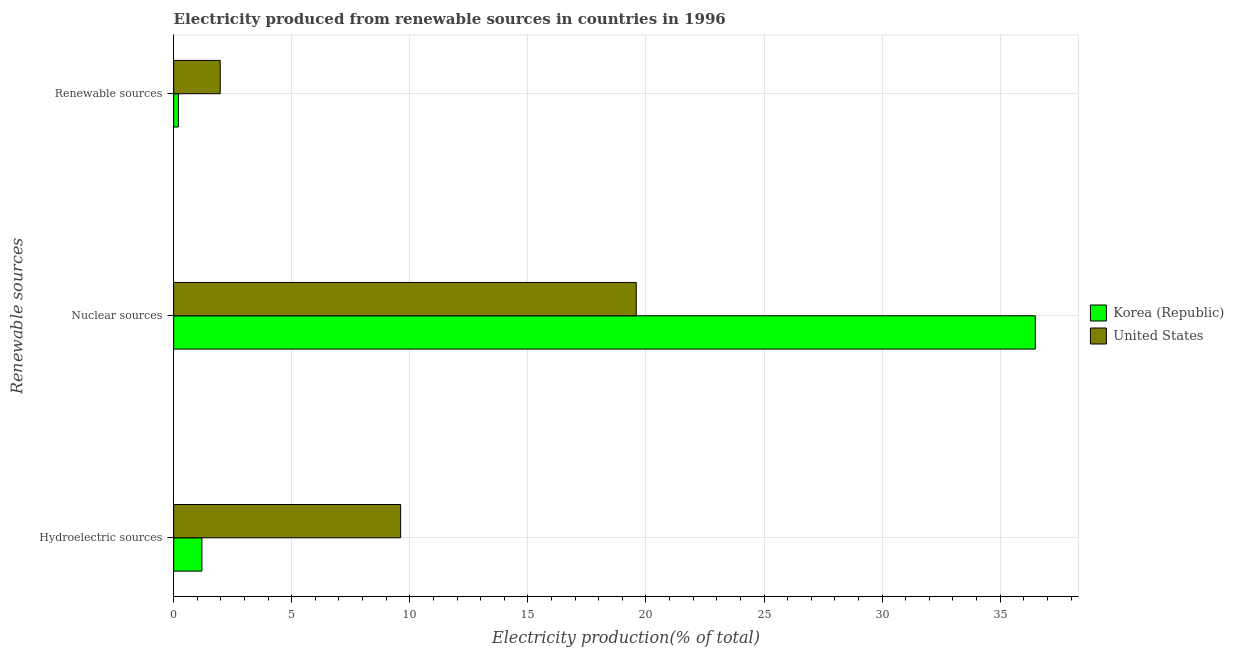How many different coloured bars are there?
Provide a succinct answer. 2. How many groups of bars are there?
Provide a short and direct response. 3. Are the number of bars per tick equal to the number of legend labels?
Offer a very short reply. Yes. Are the number of bars on each tick of the Y-axis equal?
Your response must be concise. Yes. How many bars are there on the 1st tick from the bottom?
Your answer should be very brief. 2. What is the label of the 2nd group of bars from the top?
Ensure brevity in your answer.  Nuclear sources. What is the percentage of electricity produced by hydroelectric sources in United States?
Keep it short and to the point. 9.61. Across all countries, what is the maximum percentage of electricity produced by hydroelectric sources?
Offer a terse response. 9.61. Across all countries, what is the minimum percentage of electricity produced by renewable sources?
Provide a short and direct response. 0.2. In which country was the percentage of electricity produced by hydroelectric sources maximum?
Offer a terse response. United States. What is the total percentage of electricity produced by renewable sources in the graph?
Give a very brief answer. 2.17. What is the difference between the percentage of electricity produced by nuclear sources in United States and that in Korea (Republic)?
Offer a terse response. -16.9. What is the difference between the percentage of electricity produced by nuclear sources in Korea (Republic) and the percentage of electricity produced by hydroelectric sources in United States?
Offer a terse response. 26.88. What is the average percentage of electricity produced by hydroelectric sources per country?
Ensure brevity in your answer.  5.4. What is the difference between the percentage of electricity produced by nuclear sources and percentage of electricity produced by hydroelectric sources in United States?
Offer a very short reply. 9.98. What is the ratio of the percentage of electricity produced by nuclear sources in Korea (Republic) to that in United States?
Your answer should be compact. 1.86. Is the difference between the percentage of electricity produced by nuclear sources in United States and Korea (Republic) greater than the difference between the percentage of electricity produced by renewable sources in United States and Korea (Republic)?
Provide a short and direct response. No. What is the difference between the highest and the second highest percentage of electricity produced by nuclear sources?
Keep it short and to the point. 16.9. What is the difference between the highest and the lowest percentage of electricity produced by hydroelectric sources?
Make the answer very short. 8.41. What does the 1st bar from the bottom in Renewable sources represents?
Your response must be concise. Korea (Republic). Is it the case that in every country, the sum of the percentage of electricity produced by hydroelectric sources and percentage of electricity produced by nuclear sources is greater than the percentage of electricity produced by renewable sources?
Keep it short and to the point. Yes. How many bars are there?
Your answer should be compact. 6. Are all the bars in the graph horizontal?
Provide a short and direct response. Yes. How many countries are there in the graph?
Your answer should be very brief. 2. Does the graph contain grids?
Your response must be concise. Yes. How many legend labels are there?
Your answer should be very brief. 2. What is the title of the graph?
Give a very brief answer. Electricity produced from renewable sources in countries in 1996. Does "Vanuatu" appear as one of the legend labels in the graph?
Ensure brevity in your answer.  No. What is the label or title of the X-axis?
Offer a terse response. Electricity production(% of total). What is the label or title of the Y-axis?
Provide a short and direct response. Renewable sources. What is the Electricity production(% of total) in Korea (Republic) in Hydroelectric sources?
Keep it short and to the point. 1.2. What is the Electricity production(% of total) of United States in Hydroelectric sources?
Ensure brevity in your answer.  9.61. What is the Electricity production(% of total) of Korea (Republic) in Nuclear sources?
Keep it short and to the point. 36.49. What is the Electricity production(% of total) of United States in Nuclear sources?
Your answer should be very brief. 19.59. What is the Electricity production(% of total) in Korea (Republic) in Renewable sources?
Your response must be concise. 0.2. What is the Electricity production(% of total) of United States in Renewable sources?
Ensure brevity in your answer.  1.97. Across all Renewable sources, what is the maximum Electricity production(% of total) of Korea (Republic)?
Provide a succinct answer. 36.49. Across all Renewable sources, what is the maximum Electricity production(% of total) in United States?
Give a very brief answer. 19.59. Across all Renewable sources, what is the minimum Electricity production(% of total) in Korea (Republic)?
Ensure brevity in your answer.  0.2. Across all Renewable sources, what is the minimum Electricity production(% of total) of United States?
Make the answer very short. 1.97. What is the total Electricity production(% of total) of Korea (Republic) in the graph?
Make the answer very short. 37.88. What is the total Electricity production(% of total) of United States in the graph?
Provide a short and direct response. 31.17. What is the difference between the Electricity production(% of total) in Korea (Republic) in Hydroelectric sources and that in Nuclear sources?
Provide a short and direct response. -35.29. What is the difference between the Electricity production(% of total) of United States in Hydroelectric sources and that in Nuclear sources?
Give a very brief answer. -9.98. What is the difference between the Electricity production(% of total) of Korea (Republic) in Hydroelectric sources and that in Renewable sources?
Offer a very short reply. 1. What is the difference between the Electricity production(% of total) in United States in Hydroelectric sources and that in Renewable sources?
Offer a very short reply. 7.64. What is the difference between the Electricity production(% of total) in Korea (Republic) in Nuclear sources and that in Renewable sources?
Your answer should be compact. 36.29. What is the difference between the Electricity production(% of total) in United States in Nuclear sources and that in Renewable sources?
Ensure brevity in your answer.  17.62. What is the difference between the Electricity production(% of total) of Korea (Republic) in Hydroelectric sources and the Electricity production(% of total) of United States in Nuclear sources?
Offer a very short reply. -18.39. What is the difference between the Electricity production(% of total) of Korea (Republic) in Hydroelectric sources and the Electricity production(% of total) of United States in Renewable sources?
Give a very brief answer. -0.77. What is the difference between the Electricity production(% of total) in Korea (Republic) in Nuclear sources and the Electricity production(% of total) in United States in Renewable sources?
Provide a succinct answer. 34.52. What is the average Electricity production(% of total) of Korea (Republic) per Renewable sources?
Give a very brief answer. 12.63. What is the average Electricity production(% of total) of United States per Renewable sources?
Provide a succinct answer. 10.39. What is the difference between the Electricity production(% of total) of Korea (Republic) and Electricity production(% of total) of United States in Hydroelectric sources?
Your response must be concise. -8.41. What is the difference between the Electricity production(% of total) of Korea (Republic) and Electricity production(% of total) of United States in Nuclear sources?
Your answer should be compact. 16.9. What is the difference between the Electricity production(% of total) in Korea (Republic) and Electricity production(% of total) in United States in Renewable sources?
Make the answer very short. -1.77. What is the ratio of the Electricity production(% of total) in Korea (Republic) in Hydroelectric sources to that in Nuclear sources?
Provide a short and direct response. 0.03. What is the ratio of the Electricity production(% of total) of United States in Hydroelectric sources to that in Nuclear sources?
Make the answer very short. 0.49. What is the ratio of the Electricity production(% of total) in Korea (Republic) in Hydroelectric sources to that in Renewable sources?
Offer a terse response. 5.97. What is the ratio of the Electricity production(% of total) of United States in Hydroelectric sources to that in Renewable sources?
Offer a terse response. 4.88. What is the ratio of the Electricity production(% of total) of Korea (Republic) in Nuclear sources to that in Renewable sources?
Offer a very short reply. 182.08. What is the ratio of the Electricity production(% of total) in United States in Nuclear sources to that in Renewable sources?
Offer a very short reply. 9.94. What is the difference between the highest and the second highest Electricity production(% of total) of Korea (Republic)?
Your answer should be very brief. 35.29. What is the difference between the highest and the second highest Electricity production(% of total) of United States?
Provide a short and direct response. 9.98. What is the difference between the highest and the lowest Electricity production(% of total) of Korea (Republic)?
Your answer should be compact. 36.29. What is the difference between the highest and the lowest Electricity production(% of total) in United States?
Your response must be concise. 17.62. 